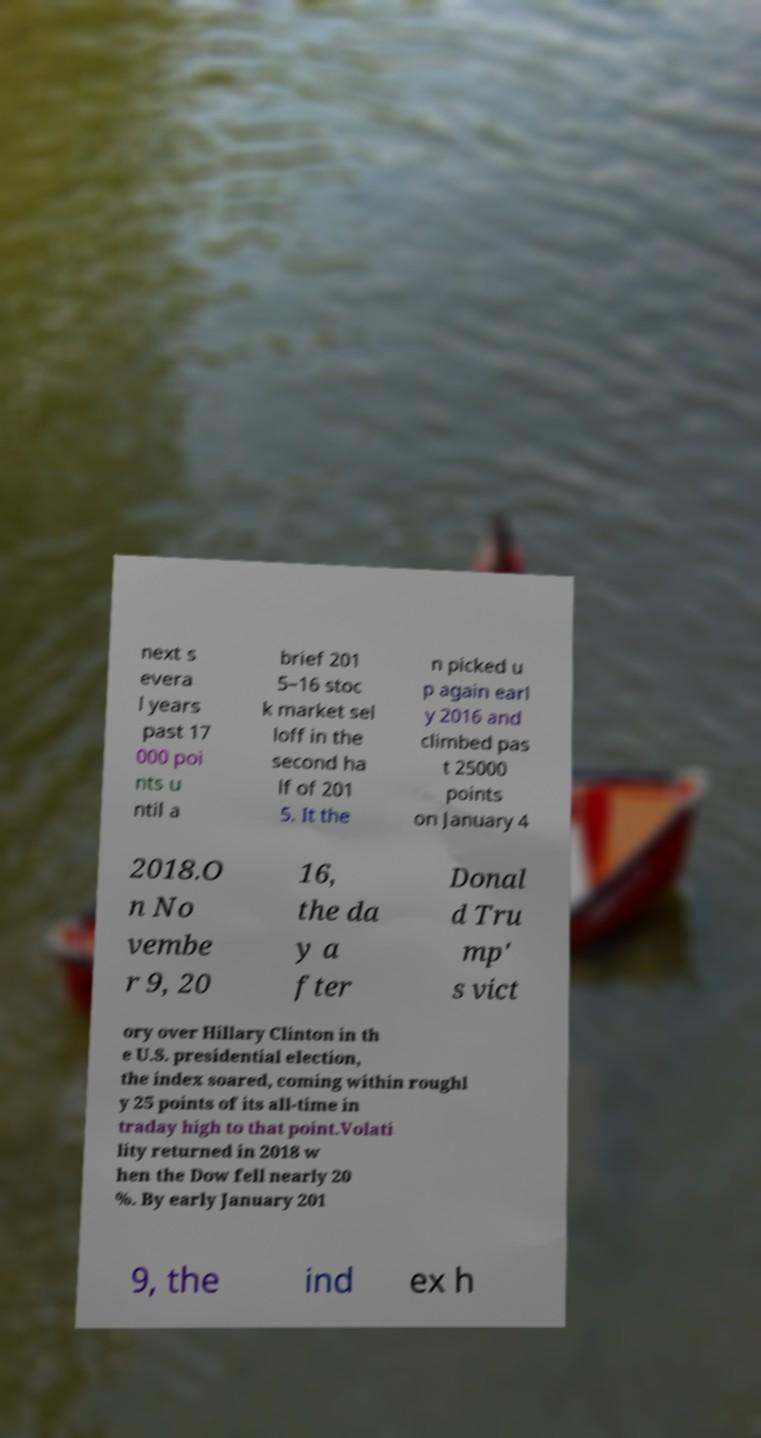What messages or text are displayed in this image? I need them in a readable, typed format. next s evera l years past 17 000 poi nts u ntil a brief 201 5–16 stoc k market sel loff in the second ha lf of 201 5. It the n picked u p again earl y 2016 and climbed pas t 25000 points on January 4 2018.O n No vembe r 9, 20 16, the da y a fter Donal d Tru mp' s vict ory over Hillary Clinton in th e U.S. presidential election, the index soared, coming within roughl y 25 points of its all-time in traday high to that point.Volati lity returned in 2018 w hen the Dow fell nearly 20 %. By early January 201 9, the ind ex h 